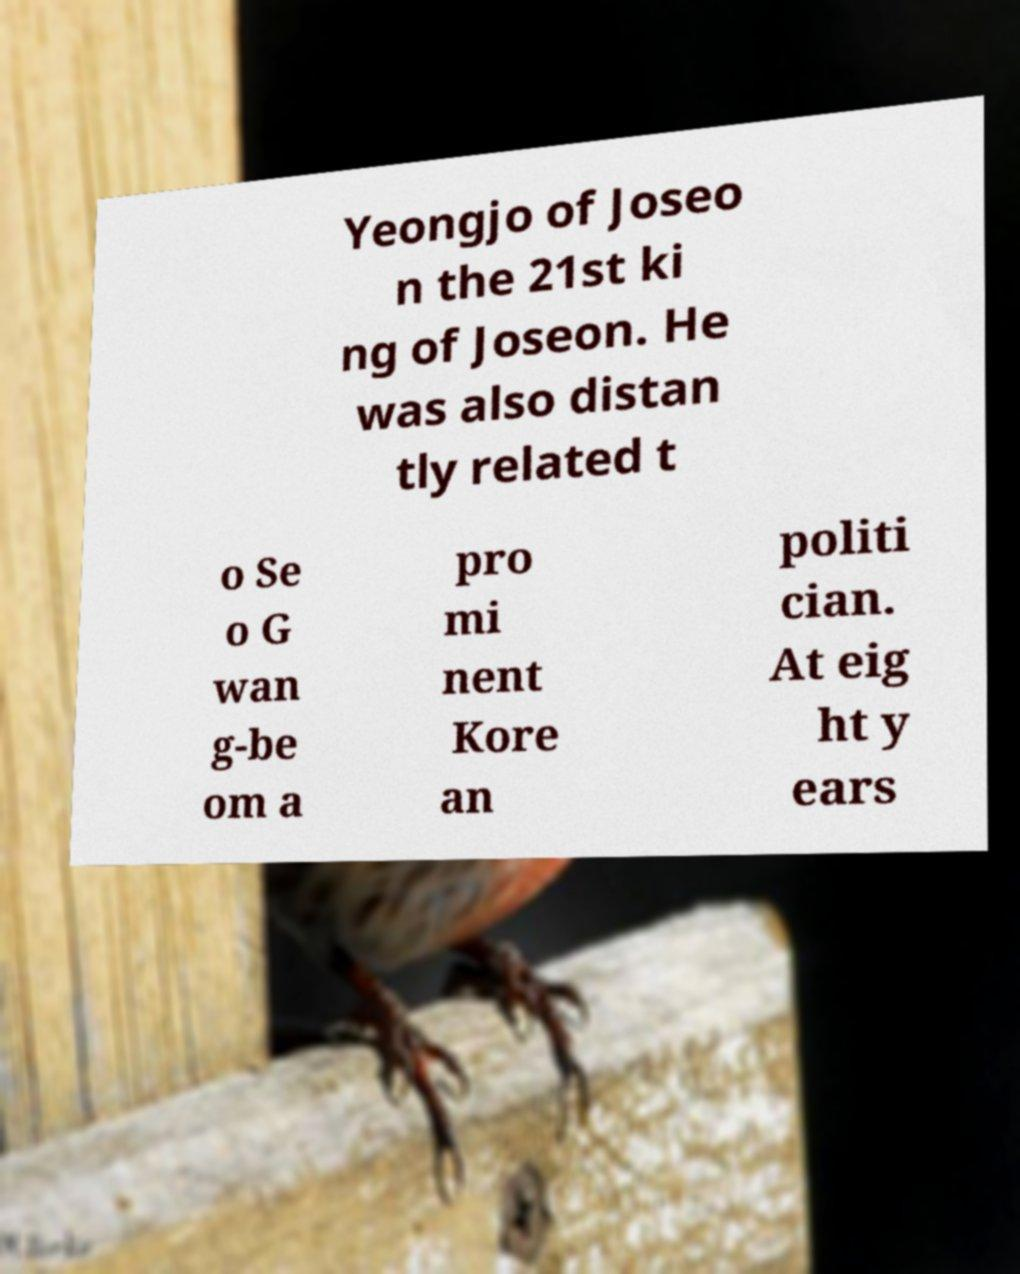For documentation purposes, I need the text within this image transcribed. Could you provide that? Yeongjo of Joseo n the 21st ki ng of Joseon. He was also distan tly related t o Se o G wan g-be om a pro mi nent Kore an politi cian. At eig ht y ears 